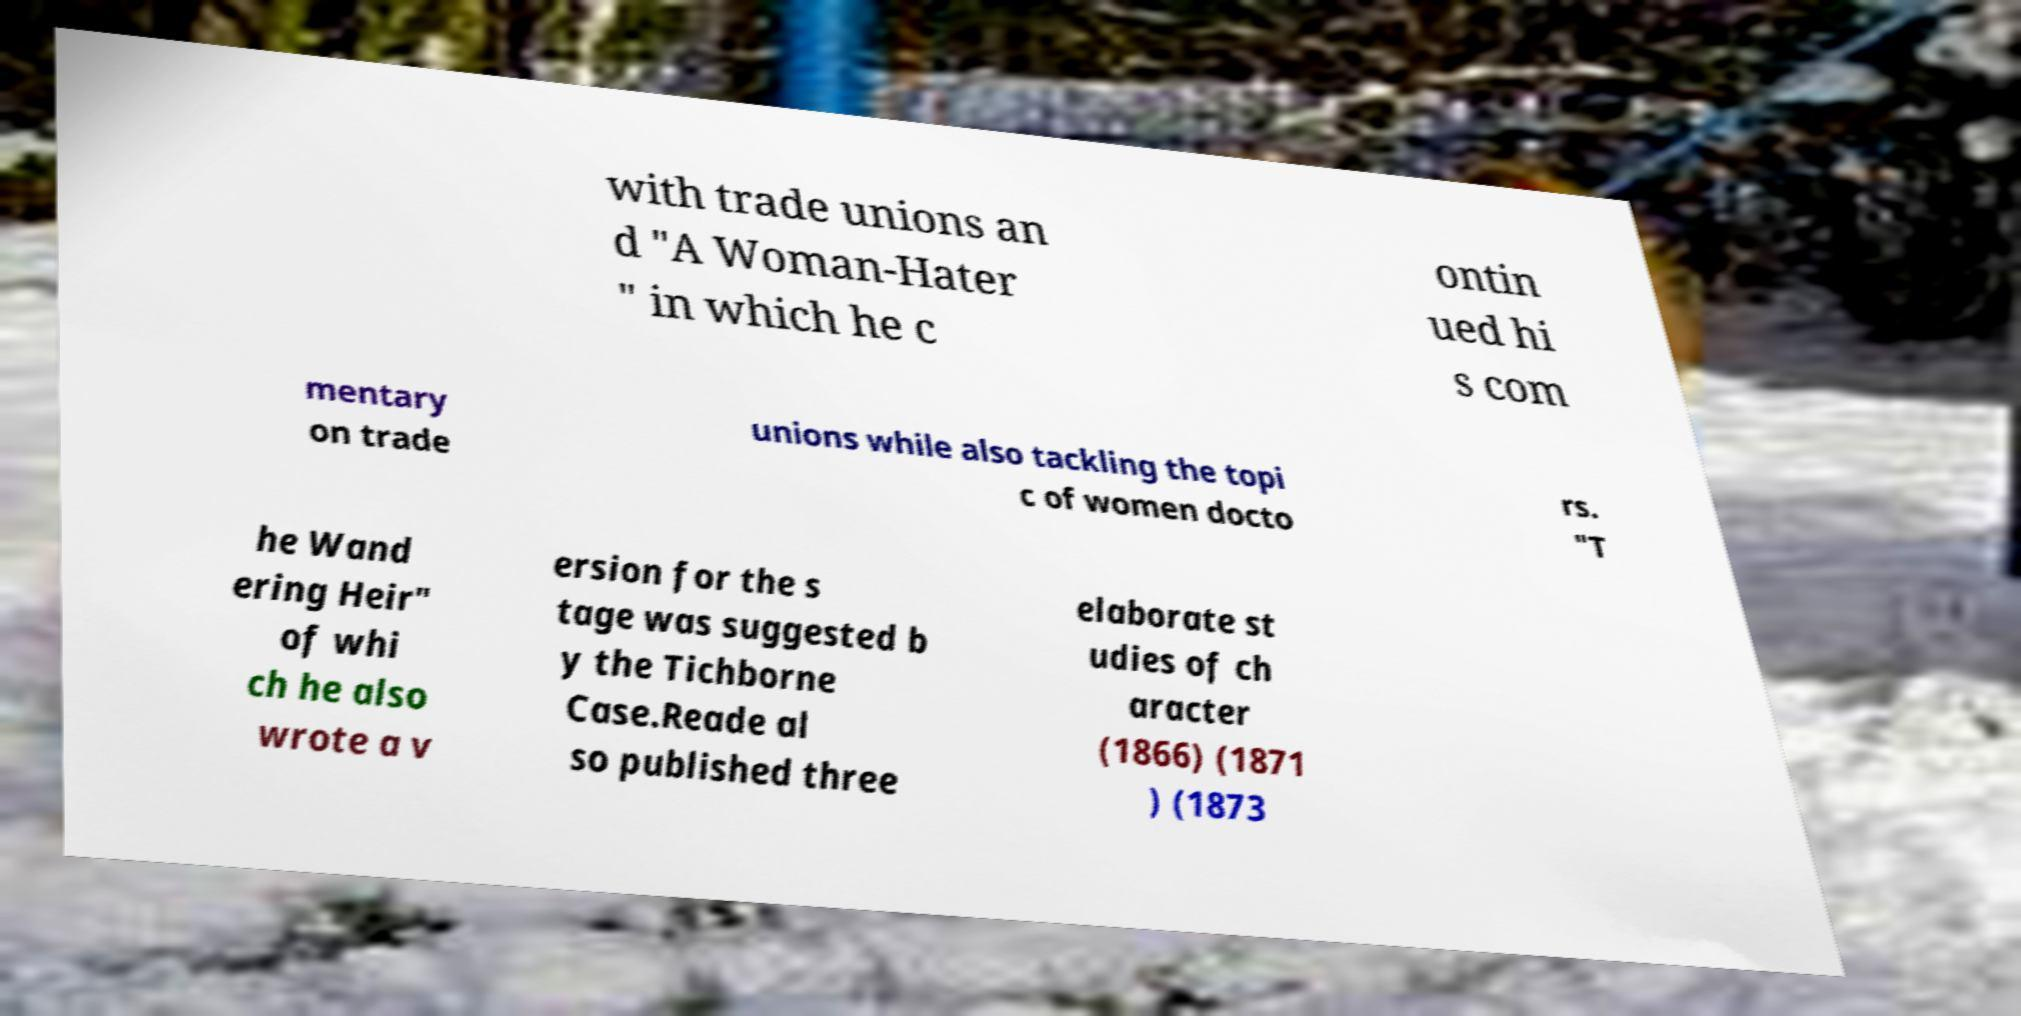Could you assist in decoding the text presented in this image and type it out clearly? with trade unions an d "A Woman-Hater " in which he c ontin ued hi s com mentary on trade unions while also tackling the topi c of women docto rs. "T he Wand ering Heir" of whi ch he also wrote a v ersion for the s tage was suggested b y the Tichborne Case.Reade al so published three elaborate st udies of ch aracter (1866) (1871 ) (1873 